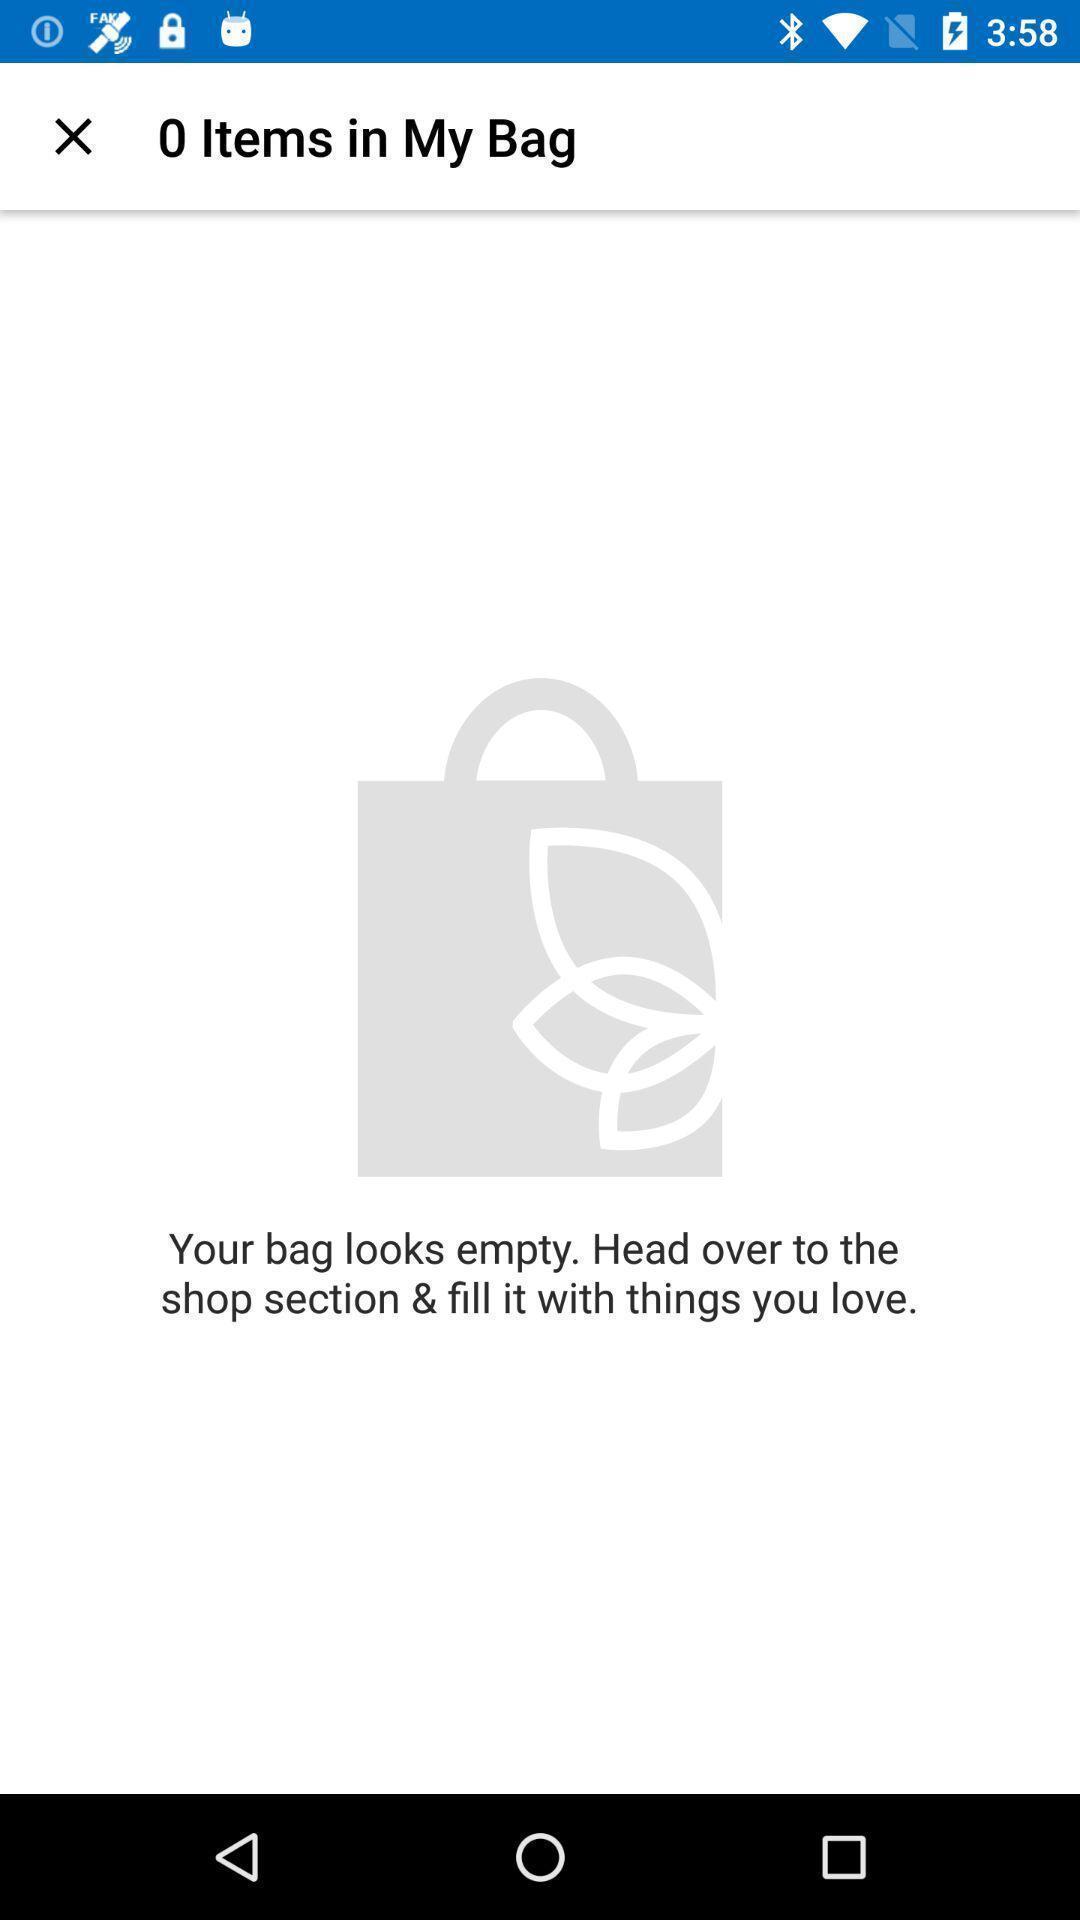What can you discern from this picture? Screen displaying cart details in a shopping application. 